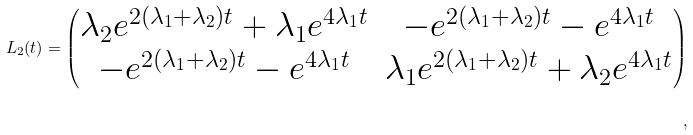Convert formula to latex. <formula><loc_0><loc_0><loc_500><loc_500>L _ { 2 } ( t ) = \left ( \begin{matrix} \lambda _ { 2 } e ^ { 2 ( \lambda _ { 1 } + \lambda _ { 2 } ) t } + \lambda _ { 1 } e ^ { 4 \lambda _ { 1 } t } & - e ^ { 2 ( \lambda _ { 1 } + \lambda _ { 2 } ) t } - e ^ { 4 \lambda _ { 1 } t } \\ - e ^ { 2 ( \lambda _ { 1 } + \lambda _ { 2 } ) t } - e ^ { 4 \lambda _ { 1 } t } & \lambda _ { 1 } e ^ { 2 ( \lambda _ { 1 } + \lambda _ { 2 } ) t } + \lambda _ { 2 } e ^ { 4 \lambda _ { 1 } t } \\ \end{matrix} \right ) \\ ,</formula> 